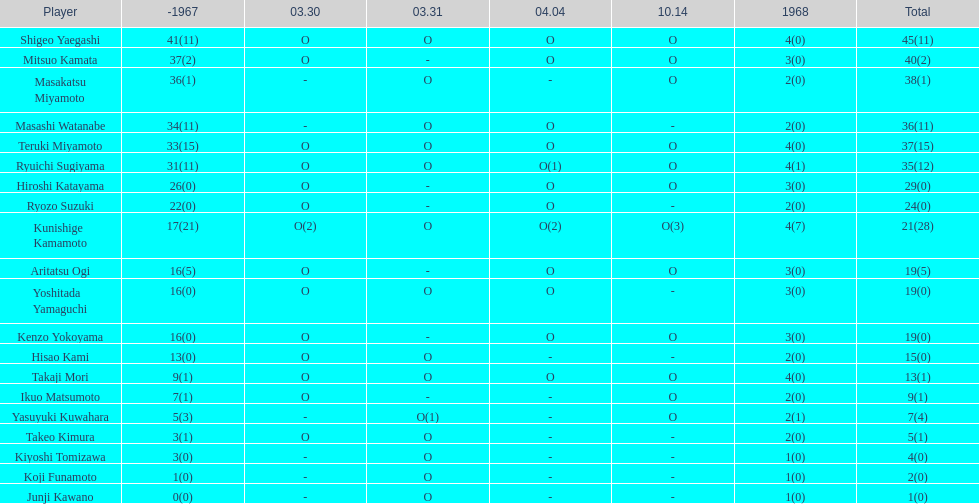Did the overall points of mitsuo kamata exceed 40? No. 